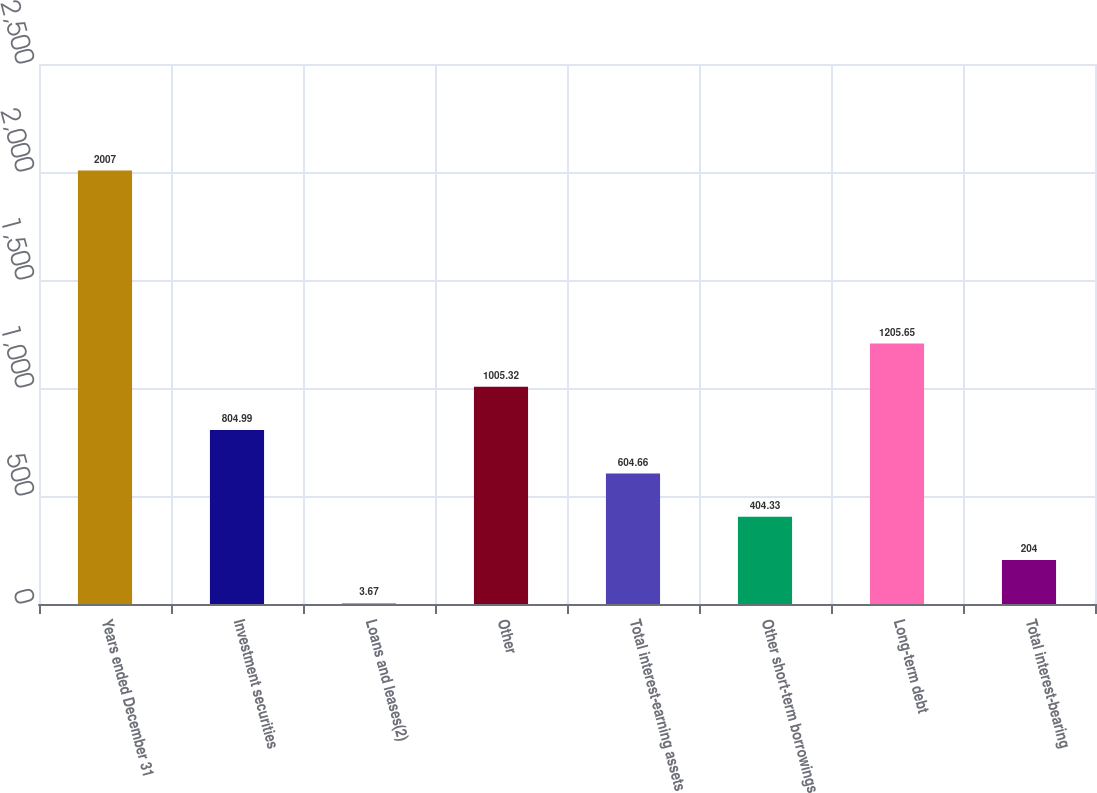Convert chart. <chart><loc_0><loc_0><loc_500><loc_500><bar_chart><fcel>Years ended December 31<fcel>Investment securities<fcel>Loans and leases(2)<fcel>Other<fcel>Total interest-earning assets<fcel>Other short-term borrowings<fcel>Long-term debt<fcel>Total interest-bearing<nl><fcel>2007<fcel>804.99<fcel>3.67<fcel>1005.32<fcel>604.66<fcel>404.33<fcel>1205.65<fcel>204<nl></chart> 